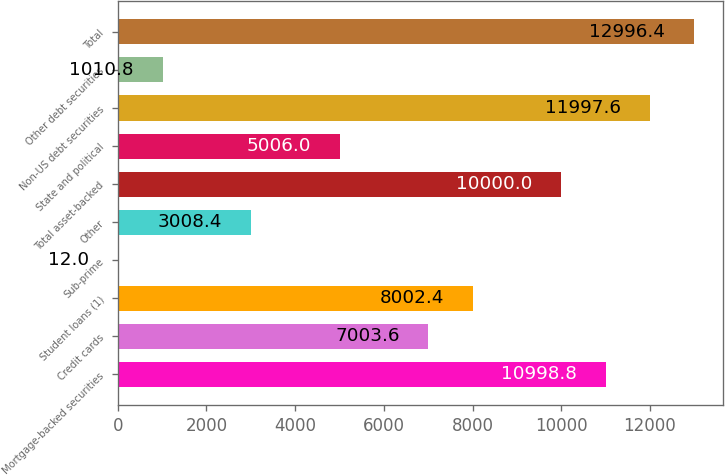Convert chart to OTSL. <chart><loc_0><loc_0><loc_500><loc_500><bar_chart><fcel>Mortgage-backed securities<fcel>Credit cards<fcel>Student loans (1)<fcel>Sub-prime<fcel>Other<fcel>Total asset-backed<fcel>State and political<fcel>Non-US debt securities<fcel>Other debt securities<fcel>Total<nl><fcel>10998.8<fcel>7003.6<fcel>8002.4<fcel>12<fcel>3008.4<fcel>10000<fcel>5006<fcel>11997.6<fcel>1010.8<fcel>12996.4<nl></chart> 